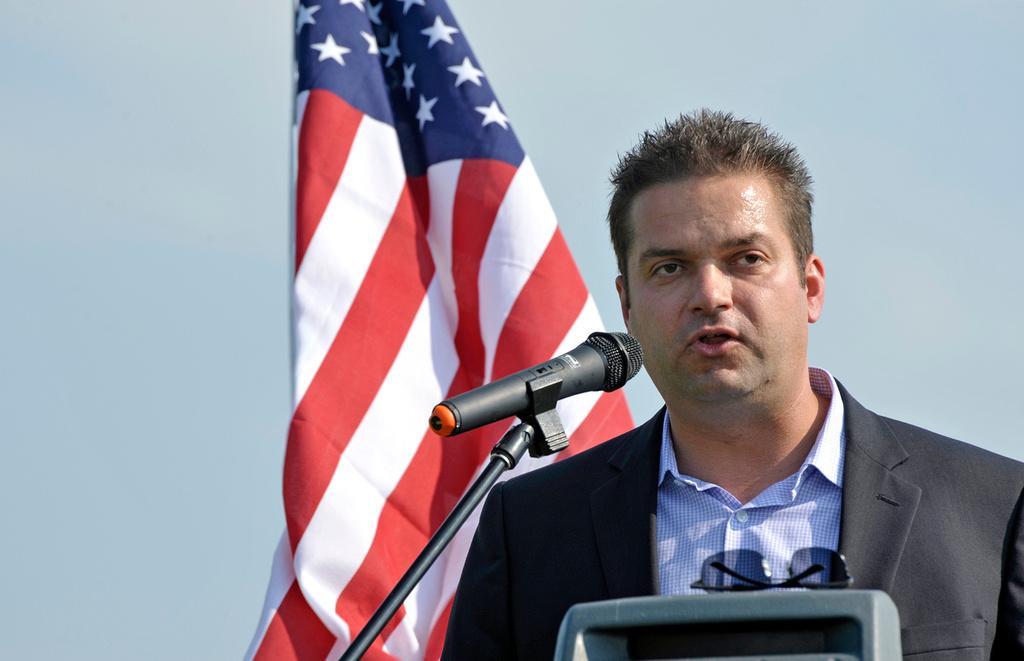Describe this image in one or two sentences. At the bottom of the image there is goggles. Behind the goggles there is a man with black jacket and blue check shirt is standing. In front of his mouth there is a mic with stand. Behind him there is a flag. 